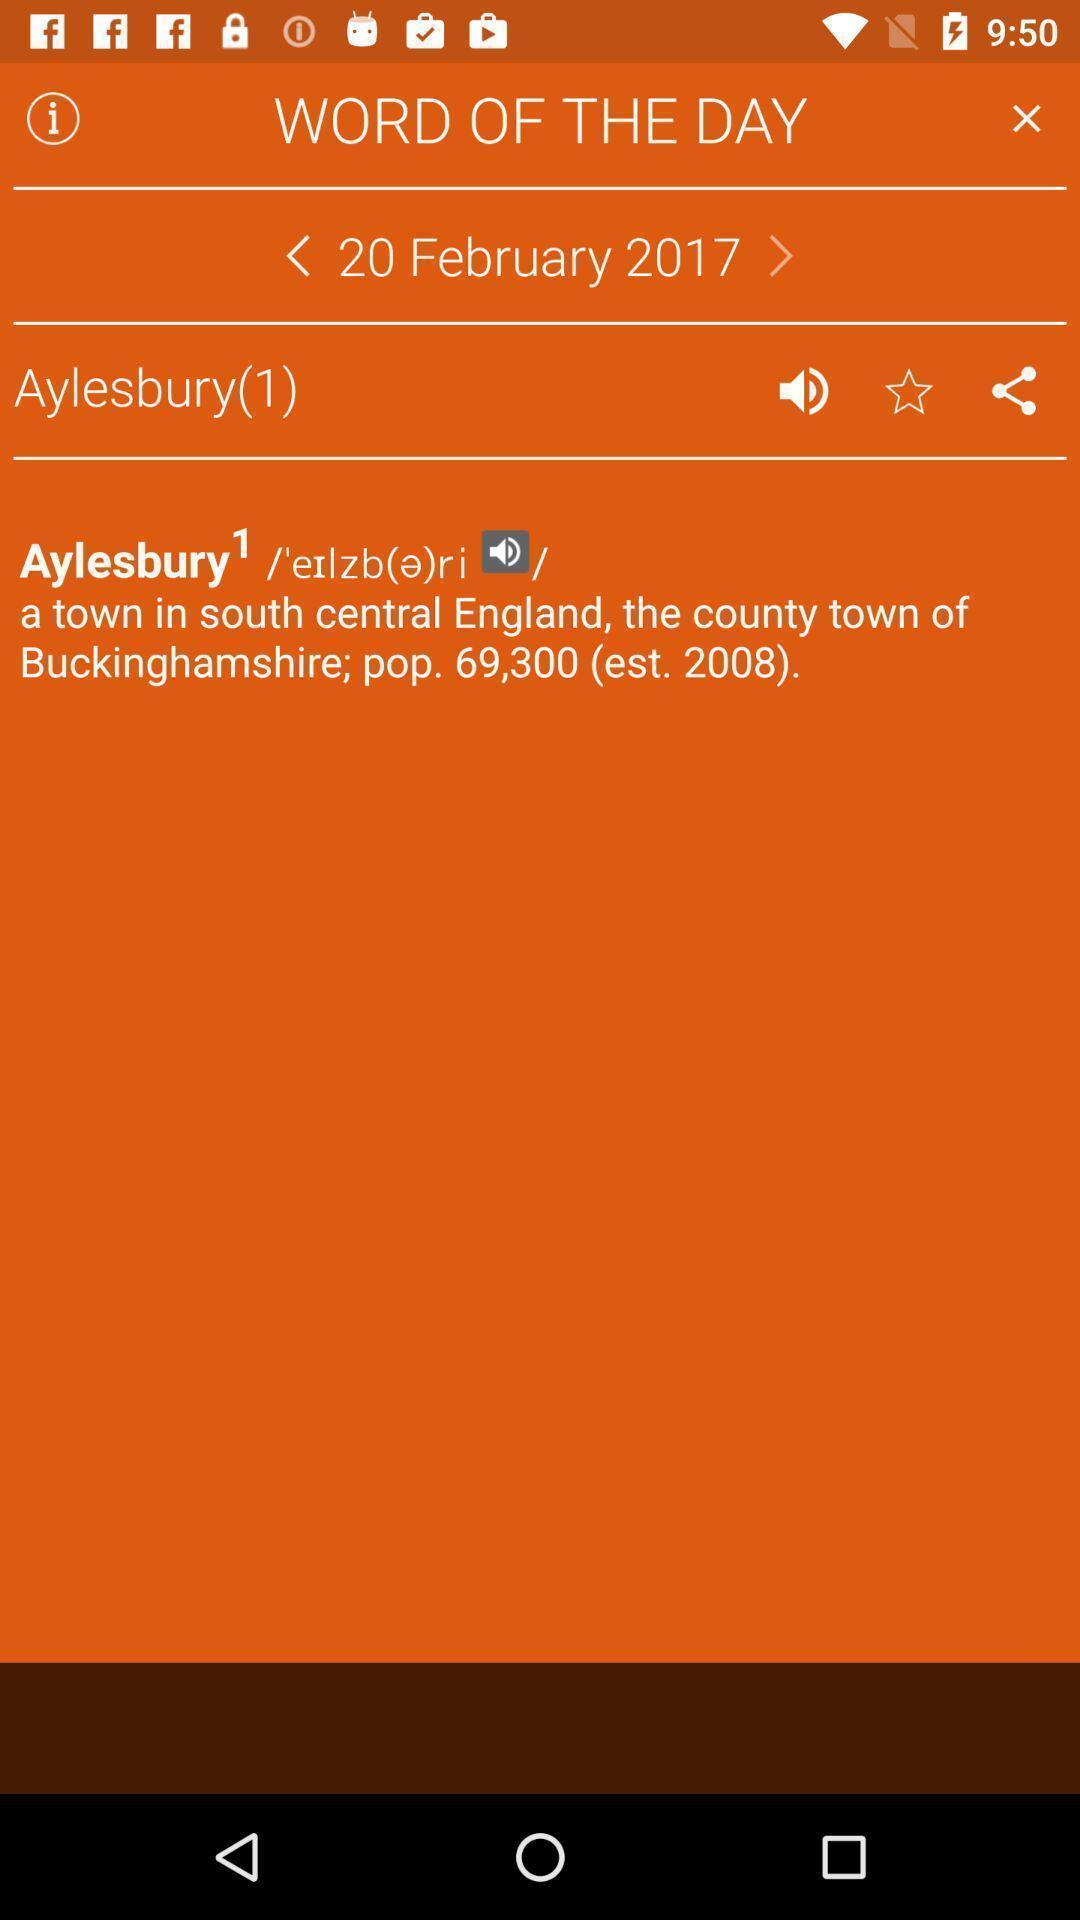Describe the key features of this screenshot. Screen displaying word of the day with audio feature. 